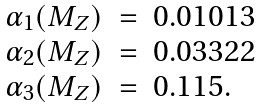Convert formula to latex. <formula><loc_0><loc_0><loc_500><loc_500>\begin{array} { l c l } \alpha _ { 1 } ( M _ { Z } ) & = & 0 . 0 1 0 1 3 \strut \\ \alpha _ { 2 } ( M _ { Z } ) & = & 0 . 0 3 3 2 2 \strut \\ \alpha _ { 3 } ( M _ { Z } ) & = & 0 . 1 1 5 . \end{array}</formula> 